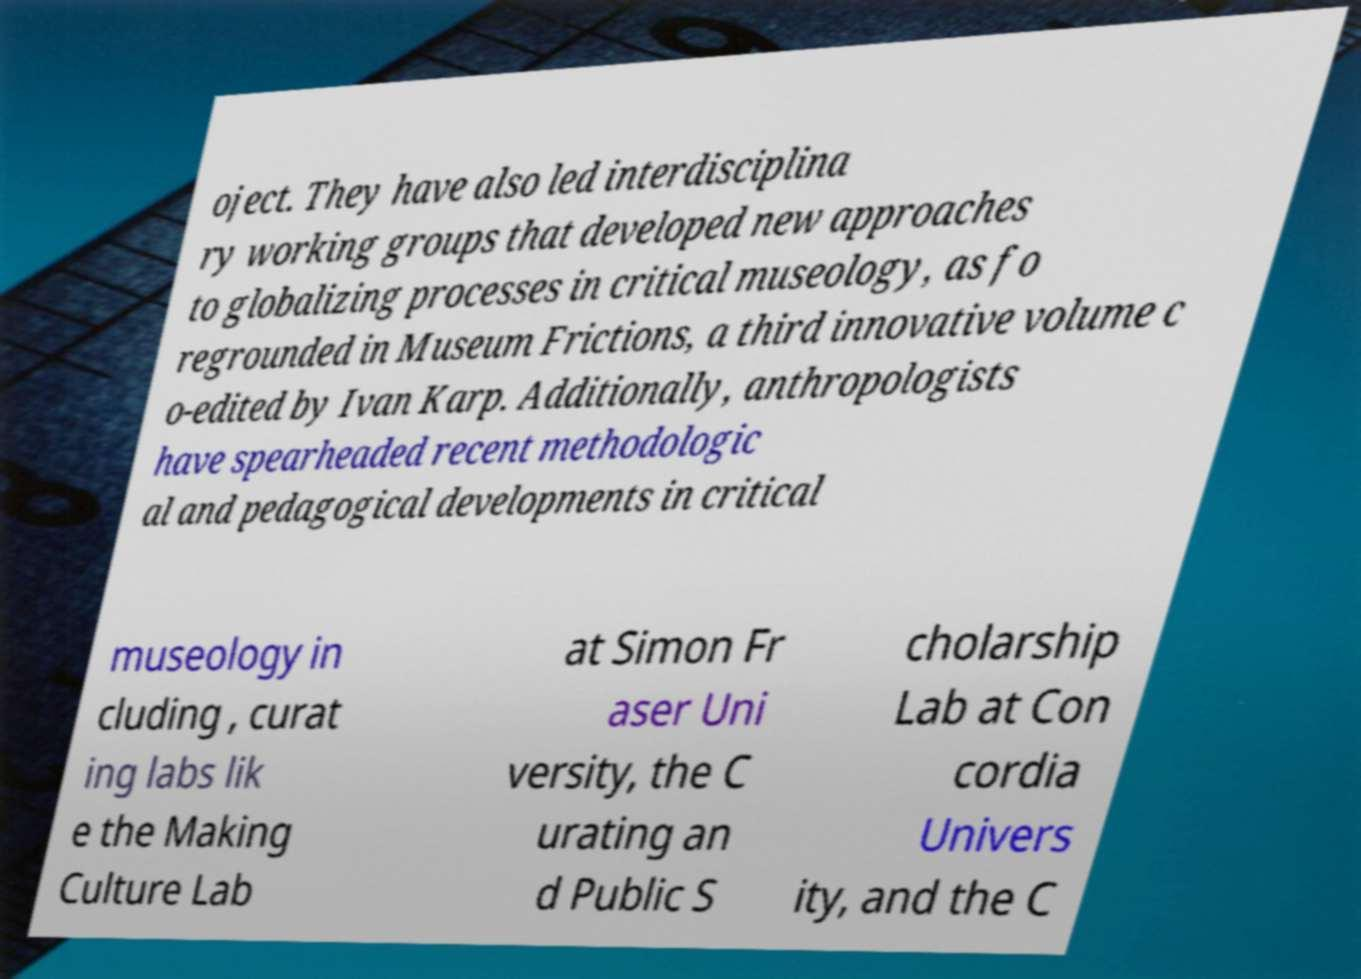Please read and relay the text visible in this image. What does it say? oject. They have also led interdisciplina ry working groups that developed new approaches to globalizing processes in critical museology, as fo regrounded in Museum Frictions, a third innovative volume c o-edited by Ivan Karp. Additionally, anthropologists have spearheaded recent methodologic al and pedagogical developments in critical museology in cluding , curat ing labs lik e the Making Culture Lab at Simon Fr aser Uni versity, the C urating an d Public S cholarship Lab at Con cordia Univers ity, and the C 